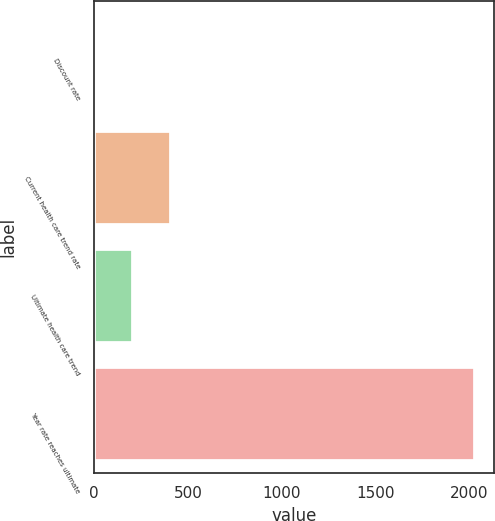Convert chart. <chart><loc_0><loc_0><loc_500><loc_500><bar_chart><fcel>Discount rate<fcel>Current health care trend rate<fcel>Ultimate health care trend<fcel>Year rate reaches ultimate<nl><fcel>3.75<fcel>409<fcel>206.38<fcel>2030<nl></chart> 